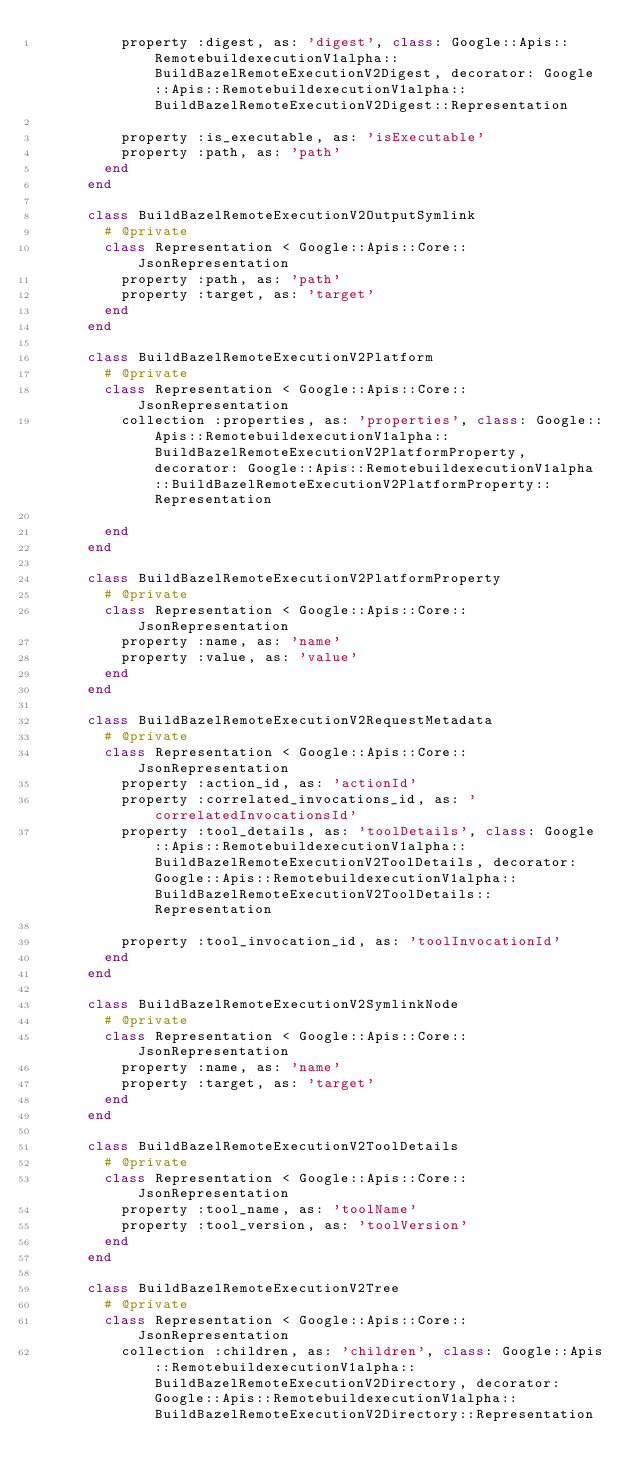<code> <loc_0><loc_0><loc_500><loc_500><_Ruby_>          property :digest, as: 'digest', class: Google::Apis::RemotebuildexecutionV1alpha::BuildBazelRemoteExecutionV2Digest, decorator: Google::Apis::RemotebuildexecutionV1alpha::BuildBazelRemoteExecutionV2Digest::Representation
      
          property :is_executable, as: 'isExecutable'
          property :path, as: 'path'
        end
      end
      
      class BuildBazelRemoteExecutionV2OutputSymlink
        # @private
        class Representation < Google::Apis::Core::JsonRepresentation
          property :path, as: 'path'
          property :target, as: 'target'
        end
      end
      
      class BuildBazelRemoteExecutionV2Platform
        # @private
        class Representation < Google::Apis::Core::JsonRepresentation
          collection :properties, as: 'properties', class: Google::Apis::RemotebuildexecutionV1alpha::BuildBazelRemoteExecutionV2PlatformProperty, decorator: Google::Apis::RemotebuildexecutionV1alpha::BuildBazelRemoteExecutionV2PlatformProperty::Representation
      
        end
      end
      
      class BuildBazelRemoteExecutionV2PlatformProperty
        # @private
        class Representation < Google::Apis::Core::JsonRepresentation
          property :name, as: 'name'
          property :value, as: 'value'
        end
      end
      
      class BuildBazelRemoteExecutionV2RequestMetadata
        # @private
        class Representation < Google::Apis::Core::JsonRepresentation
          property :action_id, as: 'actionId'
          property :correlated_invocations_id, as: 'correlatedInvocationsId'
          property :tool_details, as: 'toolDetails', class: Google::Apis::RemotebuildexecutionV1alpha::BuildBazelRemoteExecutionV2ToolDetails, decorator: Google::Apis::RemotebuildexecutionV1alpha::BuildBazelRemoteExecutionV2ToolDetails::Representation
      
          property :tool_invocation_id, as: 'toolInvocationId'
        end
      end
      
      class BuildBazelRemoteExecutionV2SymlinkNode
        # @private
        class Representation < Google::Apis::Core::JsonRepresentation
          property :name, as: 'name'
          property :target, as: 'target'
        end
      end
      
      class BuildBazelRemoteExecutionV2ToolDetails
        # @private
        class Representation < Google::Apis::Core::JsonRepresentation
          property :tool_name, as: 'toolName'
          property :tool_version, as: 'toolVersion'
        end
      end
      
      class BuildBazelRemoteExecutionV2Tree
        # @private
        class Representation < Google::Apis::Core::JsonRepresentation
          collection :children, as: 'children', class: Google::Apis::RemotebuildexecutionV1alpha::BuildBazelRemoteExecutionV2Directory, decorator: Google::Apis::RemotebuildexecutionV1alpha::BuildBazelRemoteExecutionV2Directory::Representation
      </code> 